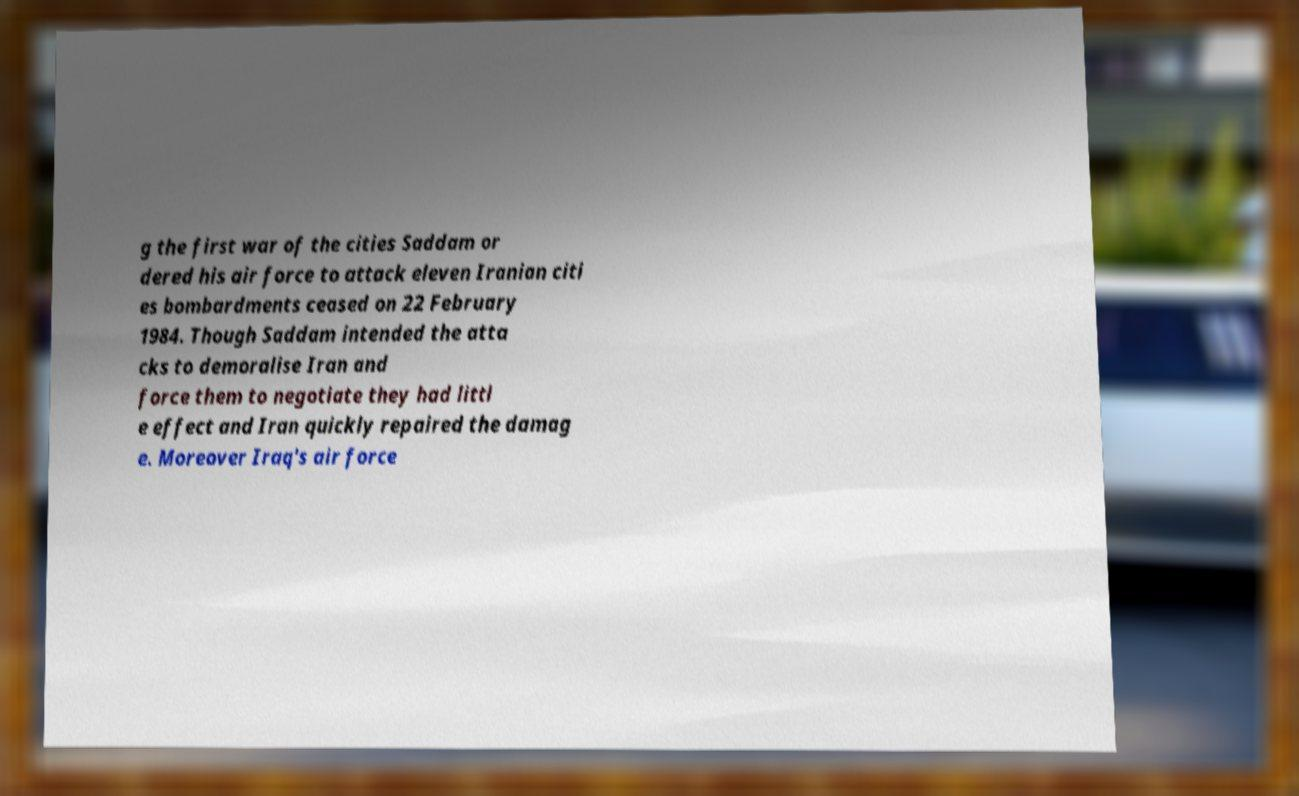Please identify and transcribe the text found in this image. g the first war of the cities Saddam or dered his air force to attack eleven Iranian citi es bombardments ceased on 22 February 1984. Though Saddam intended the atta cks to demoralise Iran and force them to negotiate they had littl e effect and Iran quickly repaired the damag e. Moreover Iraq's air force 